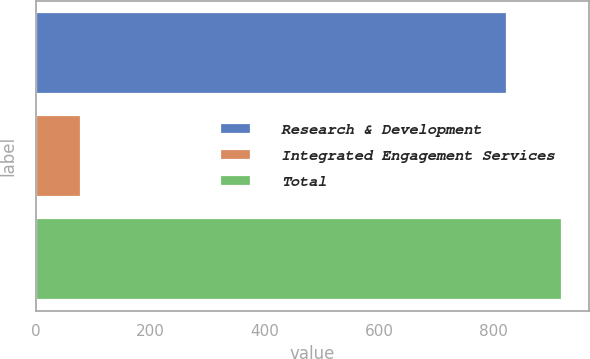<chart> <loc_0><loc_0><loc_500><loc_500><bar_chart><fcel>Research & Development<fcel>Integrated Engagement Services<fcel>Total<nl><fcel>824<fcel>78<fcel>921<nl></chart> 